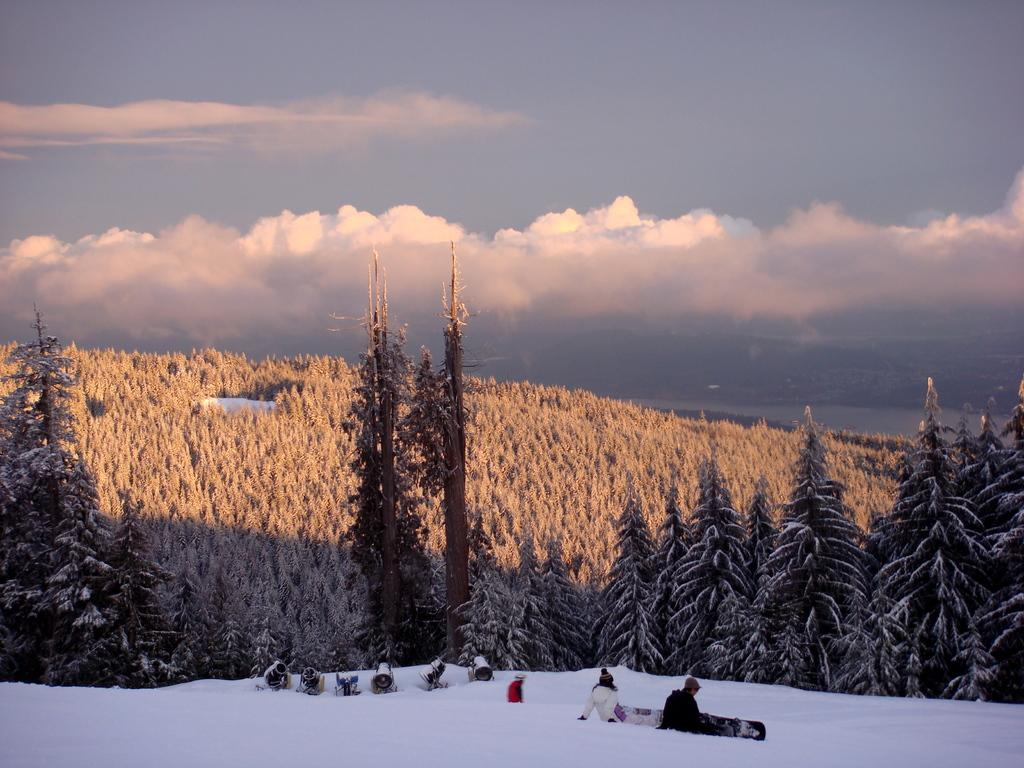What is covering the ground at the bottom of the image? There is snow at the bottom of the image. What can be seen at the top of the image? The sky is visible at the top of the image. What type of vegetation is in the middle of the image? There are trees in the middle of the image. How are the trees affected by the snow? Snow is present on the trees. Can you describe the additional objects on the snow? There are six pirangi's on the snow. What type of sail can be seen on the trees in the image? There is no sail present in the image; it features snow, trees, and pirangi's. What thoughts might the pirangi's be having in the image? Pirangi's are not capable of having thoughts, as they are objects and not living beings. 